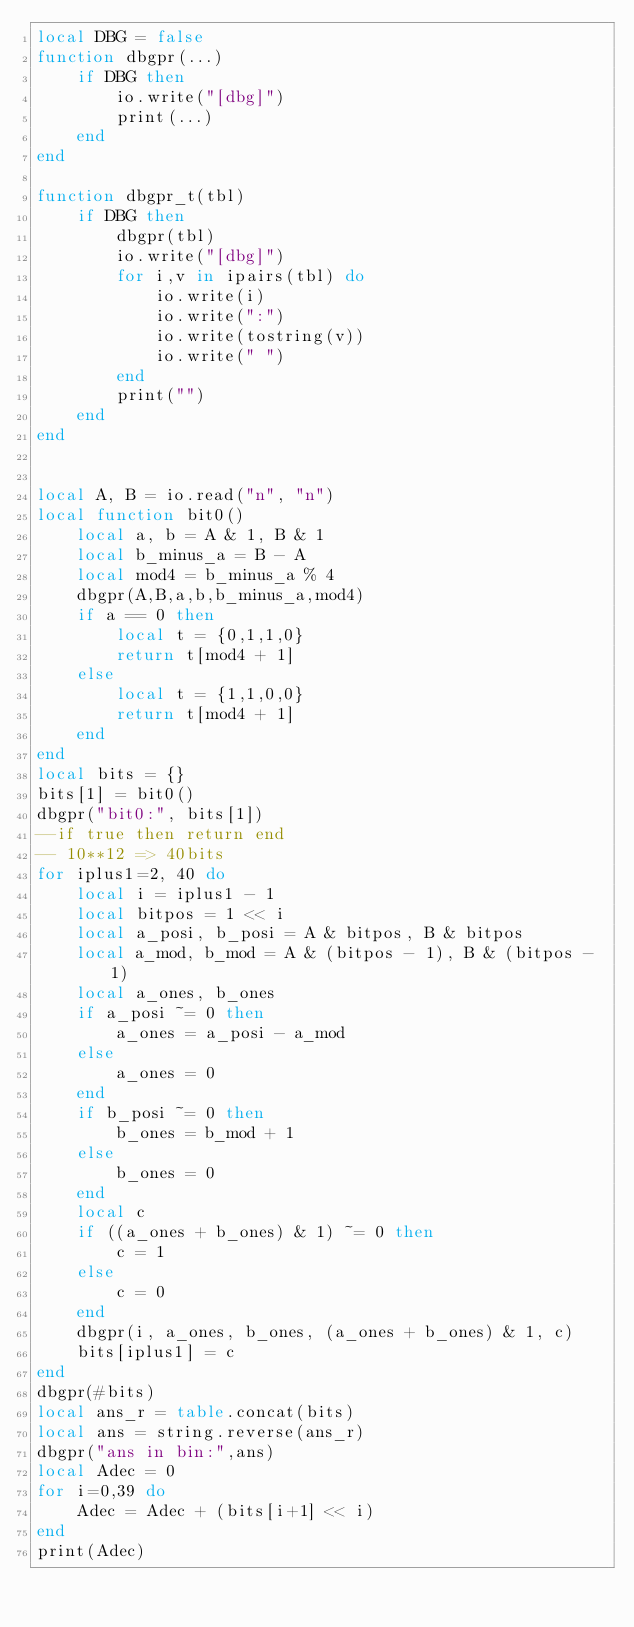<code> <loc_0><loc_0><loc_500><loc_500><_Lua_>local DBG = false
function dbgpr(...)
    if DBG then
        io.write("[dbg]")
        print(...)
    end
end

function dbgpr_t(tbl)
    if DBG then
        dbgpr(tbl)
        io.write("[dbg]")
        for i,v in ipairs(tbl) do
            io.write(i)
            io.write(":")
            io.write(tostring(v))
            io.write(" ")
        end
        print("")
    end
end


local A, B = io.read("n", "n")
local function bit0()
    local a, b = A & 1, B & 1
    local b_minus_a = B - A
    local mod4 = b_minus_a % 4
    dbgpr(A,B,a,b,b_minus_a,mod4)
    if a == 0 then
        local t = {0,1,1,0}
        return t[mod4 + 1]
    else
        local t = {1,1,0,0}
        return t[mod4 + 1]
    end
end
local bits = {}
bits[1] = bit0()
dbgpr("bit0:", bits[1])
--if true then return end
-- 10**12 => 40bits
for iplus1=2, 40 do
    local i = iplus1 - 1
    local bitpos = 1 << i
    local a_posi, b_posi = A & bitpos, B & bitpos
    local a_mod, b_mod = A & (bitpos - 1), B & (bitpos - 1)
    local a_ones, b_ones
    if a_posi ~= 0 then
        a_ones = a_posi - a_mod
    else
        a_ones = 0
    end
    if b_posi ~= 0 then
        b_ones = b_mod + 1
    else
        b_ones = 0
    end
    local c
    if ((a_ones + b_ones) & 1) ~= 0 then
        c = 1
    else
        c = 0
    end
    dbgpr(i, a_ones, b_ones, (a_ones + b_ones) & 1, c)
    bits[iplus1] = c
end
dbgpr(#bits)
local ans_r = table.concat(bits)
local ans = string.reverse(ans_r)
dbgpr("ans in bin:",ans)
local Adec = 0
for i=0,39 do
    Adec = Adec + (bits[i+1] << i)
end
print(Adec)</code> 